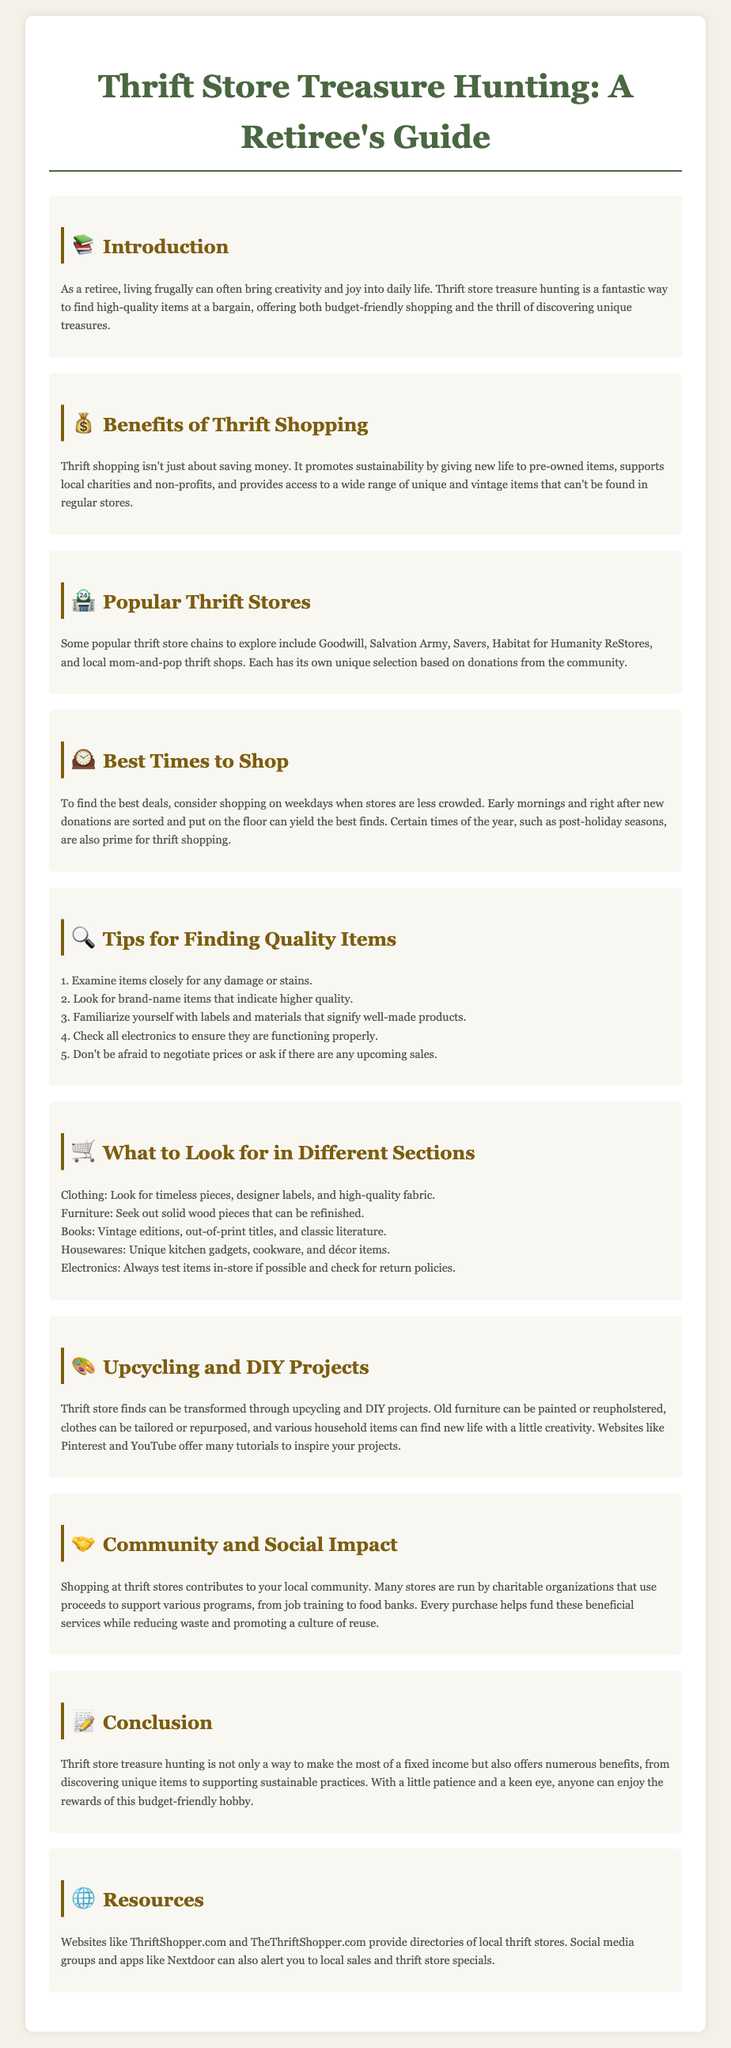What is the title of the document? The title of the document is found in the header section, which is "Thrift Store Treasure Hunting: A Retiree's Guide."
Answer: Thrift Store Treasure Hunting: A Retiree's Guide What are two popular thrift store chains mentioned? The document lists specific thrift store chains under the "Popular Thrift Stores" section, including Goodwill and Salvation Army.
Answer: Goodwill, Salvation Army What is one benefit of thrift shopping? The document highlights benefits in the "Benefits of Thrift Shopping" section, including that it promotes sustainability.
Answer: Promotes sustainability What is suggested as the best time to shop for deals? The document provides specific advice under "Best Times to Shop," indicating when it is best to shop for deals, specifically mentioning weekdays.
Answer: Weekdays How can thrift store finds be transformed? The "Upcycling and DIY Projects" section mentions how thrift store finds can be transformed through various methods, including painting or reupholstering.
Answer: Painting or reupholstering What should you look for in clothing items? In the "What to Look for in Different Sections" section, it suggests looking for timeless pieces and designer labels in clothing.
Answer: Timeless pieces, designer labels Which section covers community impact? The document has a dedicated section titled "Community and Social Impact" that discusses the effects of thrift shopping on the community.
Answer: Community and Social Impact What online resource is mentioned for finding thrift stores? The document lists websites as resources in the "Resources" section, specifically mentioning ThriftShopper.com.
Answer: ThriftShopper.com 